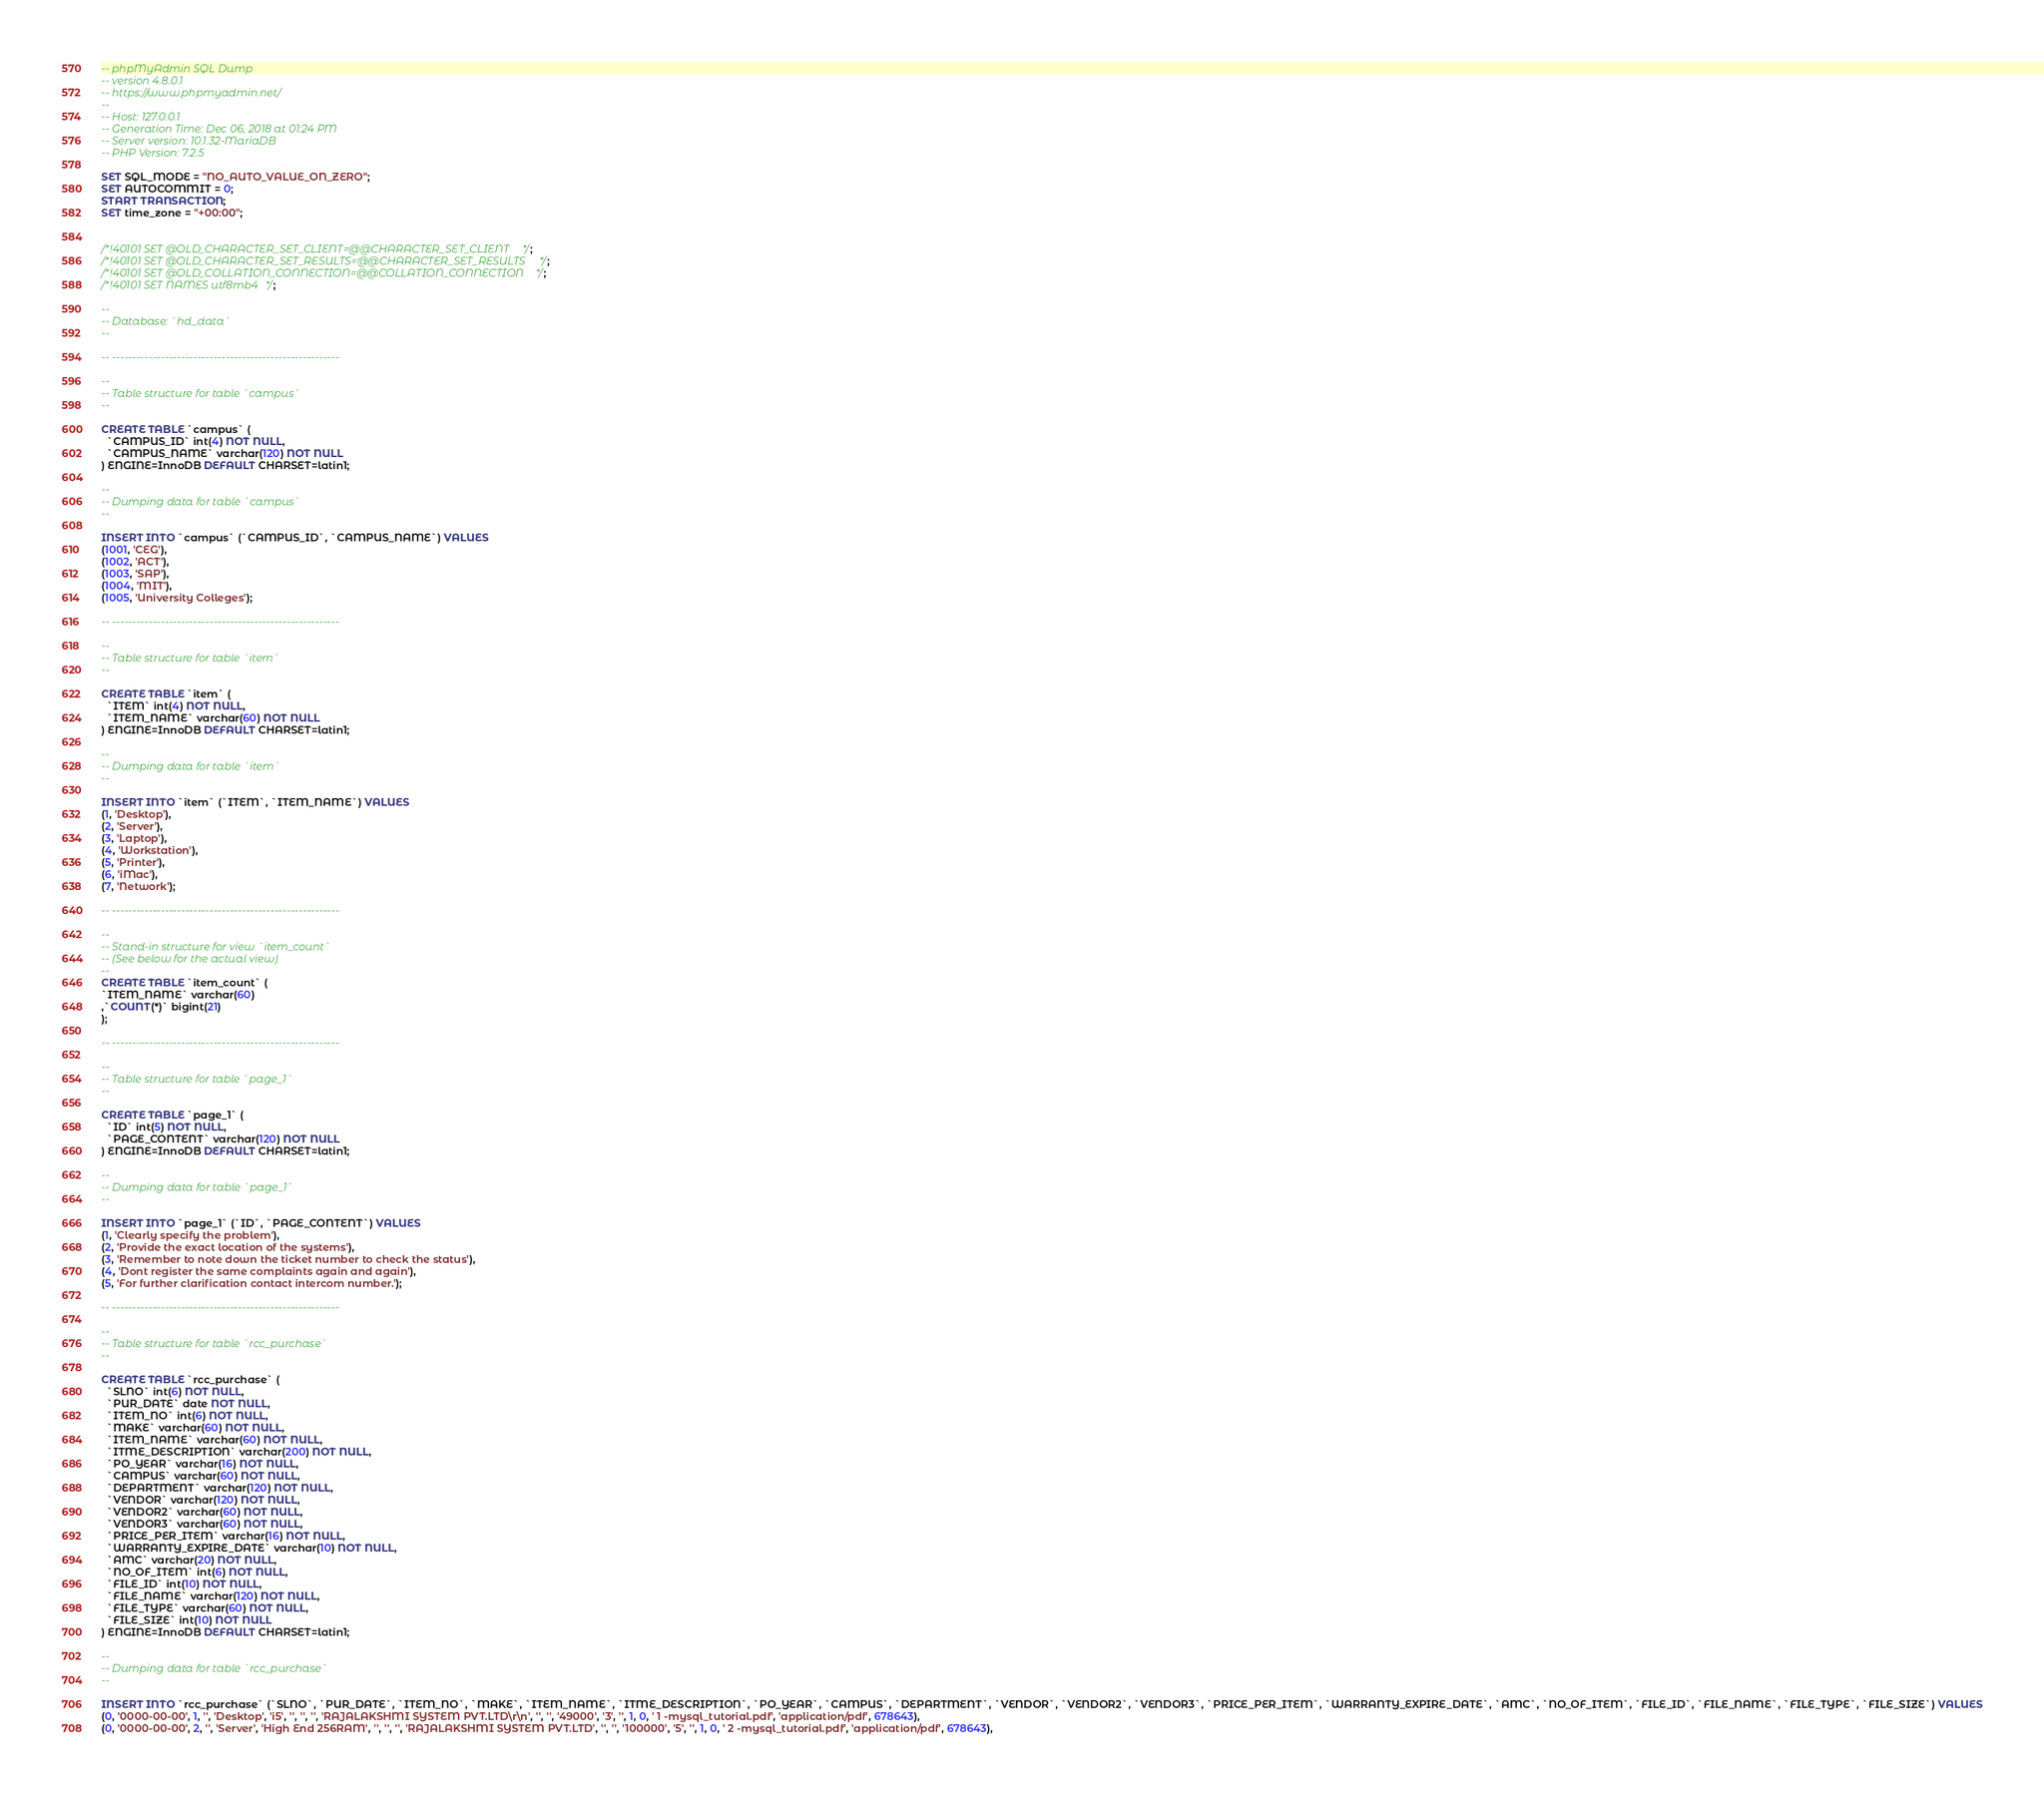Convert code to text. <code><loc_0><loc_0><loc_500><loc_500><_SQL_>-- phpMyAdmin SQL Dump
-- version 4.8.0.1
-- https://www.phpmyadmin.net/
--
-- Host: 127.0.0.1
-- Generation Time: Dec 06, 2018 at 01:24 PM
-- Server version: 10.1.32-MariaDB
-- PHP Version: 7.2.5

SET SQL_MODE = "NO_AUTO_VALUE_ON_ZERO";
SET AUTOCOMMIT = 0;
START TRANSACTION;
SET time_zone = "+00:00";


/*!40101 SET @OLD_CHARACTER_SET_CLIENT=@@CHARACTER_SET_CLIENT */;
/*!40101 SET @OLD_CHARACTER_SET_RESULTS=@@CHARACTER_SET_RESULTS */;
/*!40101 SET @OLD_COLLATION_CONNECTION=@@COLLATION_CONNECTION */;
/*!40101 SET NAMES utf8mb4 */;

--
-- Database: `hd_data`
--

-- --------------------------------------------------------

--
-- Table structure for table `campus`
--

CREATE TABLE `campus` (
  `CAMPUS_ID` int(4) NOT NULL,
  `CAMPUS_NAME` varchar(120) NOT NULL
) ENGINE=InnoDB DEFAULT CHARSET=latin1;

--
-- Dumping data for table `campus`
--

INSERT INTO `campus` (`CAMPUS_ID`, `CAMPUS_NAME`) VALUES
(1001, 'CEG'),
(1002, 'ACT'),
(1003, 'SAP'),
(1004, 'MIT'),
(1005, 'University Colleges');

-- --------------------------------------------------------

--
-- Table structure for table `item`
--

CREATE TABLE `item` (
  `ITEM` int(4) NOT NULL,
  `ITEM_NAME` varchar(60) NOT NULL
) ENGINE=InnoDB DEFAULT CHARSET=latin1;

--
-- Dumping data for table `item`
--

INSERT INTO `item` (`ITEM`, `ITEM_NAME`) VALUES
(1, 'Desktop'),
(2, 'Server'),
(3, 'Laptop'),
(4, 'Workstation'),
(5, 'Printer'),
(6, 'iMac'),
(7, 'Network');

-- --------------------------------------------------------

--
-- Stand-in structure for view `item_count`
-- (See below for the actual view)
--
CREATE TABLE `item_count` (
`ITEM_NAME` varchar(60)
,`COUNT(*)` bigint(21)
);

-- --------------------------------------------------------

--
-- Table structure for table `page_1`
--

CREATE TABLE `page_1` (
  `ID` int(5) NOT NULL,
  `PAGE_CONTENT` varchar(120) NOT NULL
) ENGINE=InnoDB DEFAULT CHARSET=latin1;

--
-- Dumping data for table `page_1`
--

INSERT INTO `page_1` (`ID`, `PAGE_CONTENT`) VALUES
(1, 'Clearly specify the problem'),
(2, 'Provide the exact location of the systems'),
(3, 'Remember to note down the ticket number to check the status'),
(4, 'Dont register the same complaints again and again'),
(5, 'For further clarification contact intercom number.');

-- --------------------------------------------------------

--
-- Table structure for table `rcc_purchase`
--

CREATE TABLE `rcc_purchase` (
  `SLNO` int(6) NOT NULL,
  `PUR_DATE` date NOT NULL,
  `ITEM_NO` int(6) NOT NULL,
  `MAKE` varchar(60) NOT NULL,
  `ITEM_NAME` varchar(60) NOT NULL,
  `ITME_DESCRIPTION` varchar(200) NOT NULL,
  `PO_YEAR` varchar(16) NOT NULL,
  `CAMPUS` varchar(60) NOT NULL,
  `DEPARTMENT` varchar(120) NOT NULL,
  `VENDOR` varchar(120) NOT NULL,
  `VENDOR2` varchar(60) NOT NULL,
  `VENDOR3` varchar(60) NOT NULL,
  `PRICE_PER_ITEM` varchar(16) NOT NULL,
  `WARRANTY_EXPIRE_DATE` varchar(10) NOT NULL,
  `AMC` varchar(20) NOT NULL,
  `NO_OF_ITEM` int(6) NOT NULL,
  `FILE_ID` int(10) NOT NULL,
  `FILE_NAME` varchar(120) NOT NULL,
  `FILE_TYPE` varchar(60) NOT NULL,
  `FILE_SIZE` int(10) NOT NULL
) ENGINE=InnoDB DEFAULT CHARSET=latin1;

--
-- Dumping data for table `rcc_purchase`
--

INSERT INTO `rcc_purchase` (`SLNO`, `PUR_DATE`, `ITEM_NO`, `MAKE`, `ITEM_NAME`, `ITME_DESCRIPTION`, `PO_YEAR`, `CAMPUS`, `DEPARTMENT`, `VENDOR`, `VENDOR2`, `VENDOR3`, `PRICE_PER_ITEM`, `WARRANTY_EXPIRE_DATE`, `AMC`, `NO_OF_ITEM`, `FILE_ID`, `FILE_NAME`, `FILE_TYPE`, `FILE_SIZE`) VALUES
(0, '0000-00-00', 1, '', 'Desktop', 'i5', '', '', '', 'RAJALAKSHMI SYSTEM PVT.LTD\r\n', '', '', '49000', '3', '', 1, 0, ' 1 -mysql_tutorial.pdf', 'application/pdf', 678643),
(0, '0000-00-00', 2, '', 'Server', 'High End 256RAM', '', '', '', 'RAJALAKSHMI SYSTEM PVT.LTD', '', '', '100000', '5', '', 1, 0, ' 2 -mysql_tutorial.pdf', 'application/pdf', 678643),</code> 